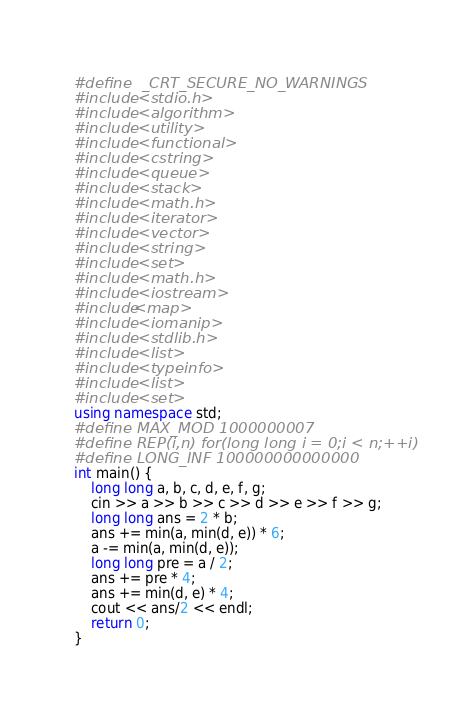Convert code to text. <code><loc_0><loc_0><loc_500><loc_500><_C++_>#define  _CRT_SECURE_NO_WARNINGS
#include <stdio.h>
#include <algorithm>
#include <utility>
#include <functional>
#include <cstring>
#include <queue>
#include <stack>
#include <math.h>
#include <iterator>
#include <vector>
#include <string>
#include <set>
#include <math.h>
#include <iostream> 
#include<map>
#include <iomanip>
#include <stdlib.h>
#include <list>
#include <typeinfo>
#include <list>
#include <set>
using namespace std;
#define MAX_MOD 1000000007
#define REP(i,n) for(long long i = 0;i < n;++i)
#define LONG_INF 100000000000000
int main() {
	long long a, b, c, d, e, f, g;
	cin >> a >> b >> c >> d >> e >> f >> g;
	long long ans = 2 * b;
	ans += min(a, min(d, e)) * 6;
	a -= min(a, min(d, e));
	long long pre = a / 2;
	ans += pre * 4;
	ans += min(d, e) * 4;
	cout << ans/2 << endl;
	return 0;
}</code> 